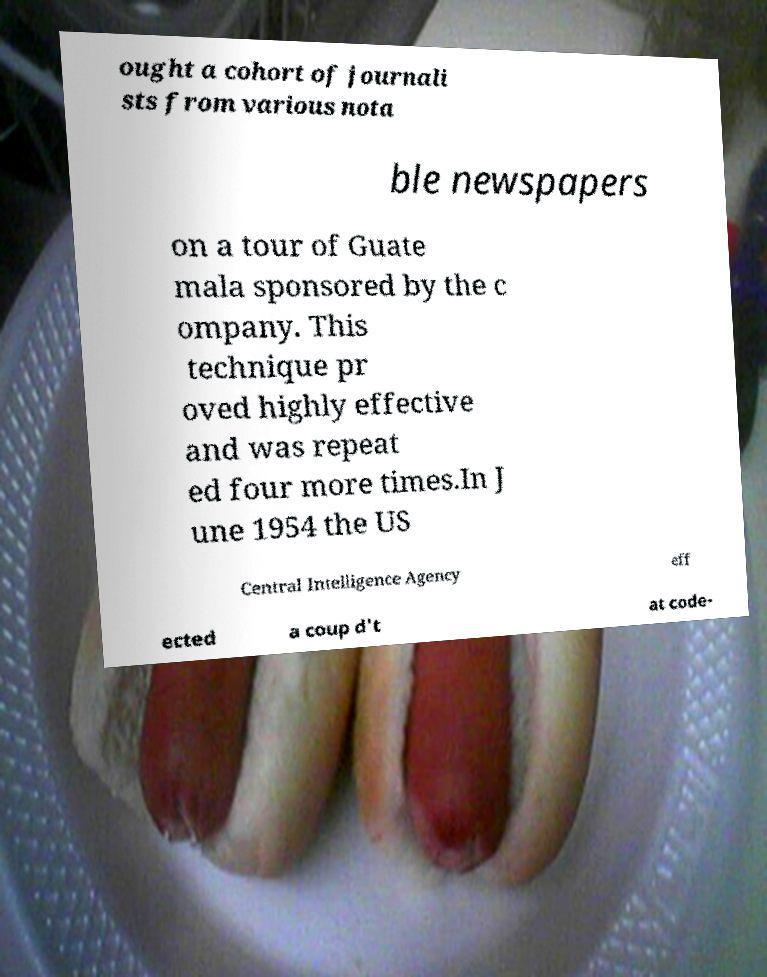What messages or text are displayed in this image? I need them in a readable, typed format. ought a cohort of journali sts from various nota ble newspapers on a tour of Guate mala sponsored by the c ompany. This technique pr oved highly effective and was repeat ed four more times.In J une 1954 the US Central Intelligence Agency eff ected a coup d't at code- 